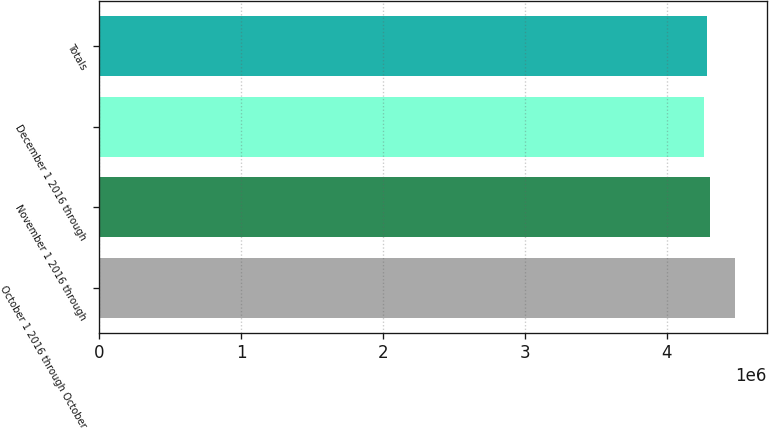Convert chart. <chart><loc_0><loc_0><loc_500><loc_500><bar_chart><fcel>October 1 2016 through October<fcel>November 1 2016 through<fcel>December 1 2016 through<fcel>Totals<nl><fcel>4.47789e+06<fcel>4.30377e+06<fcel>4.26024e+06<fcel>4.28201e+06<nl></chart> 